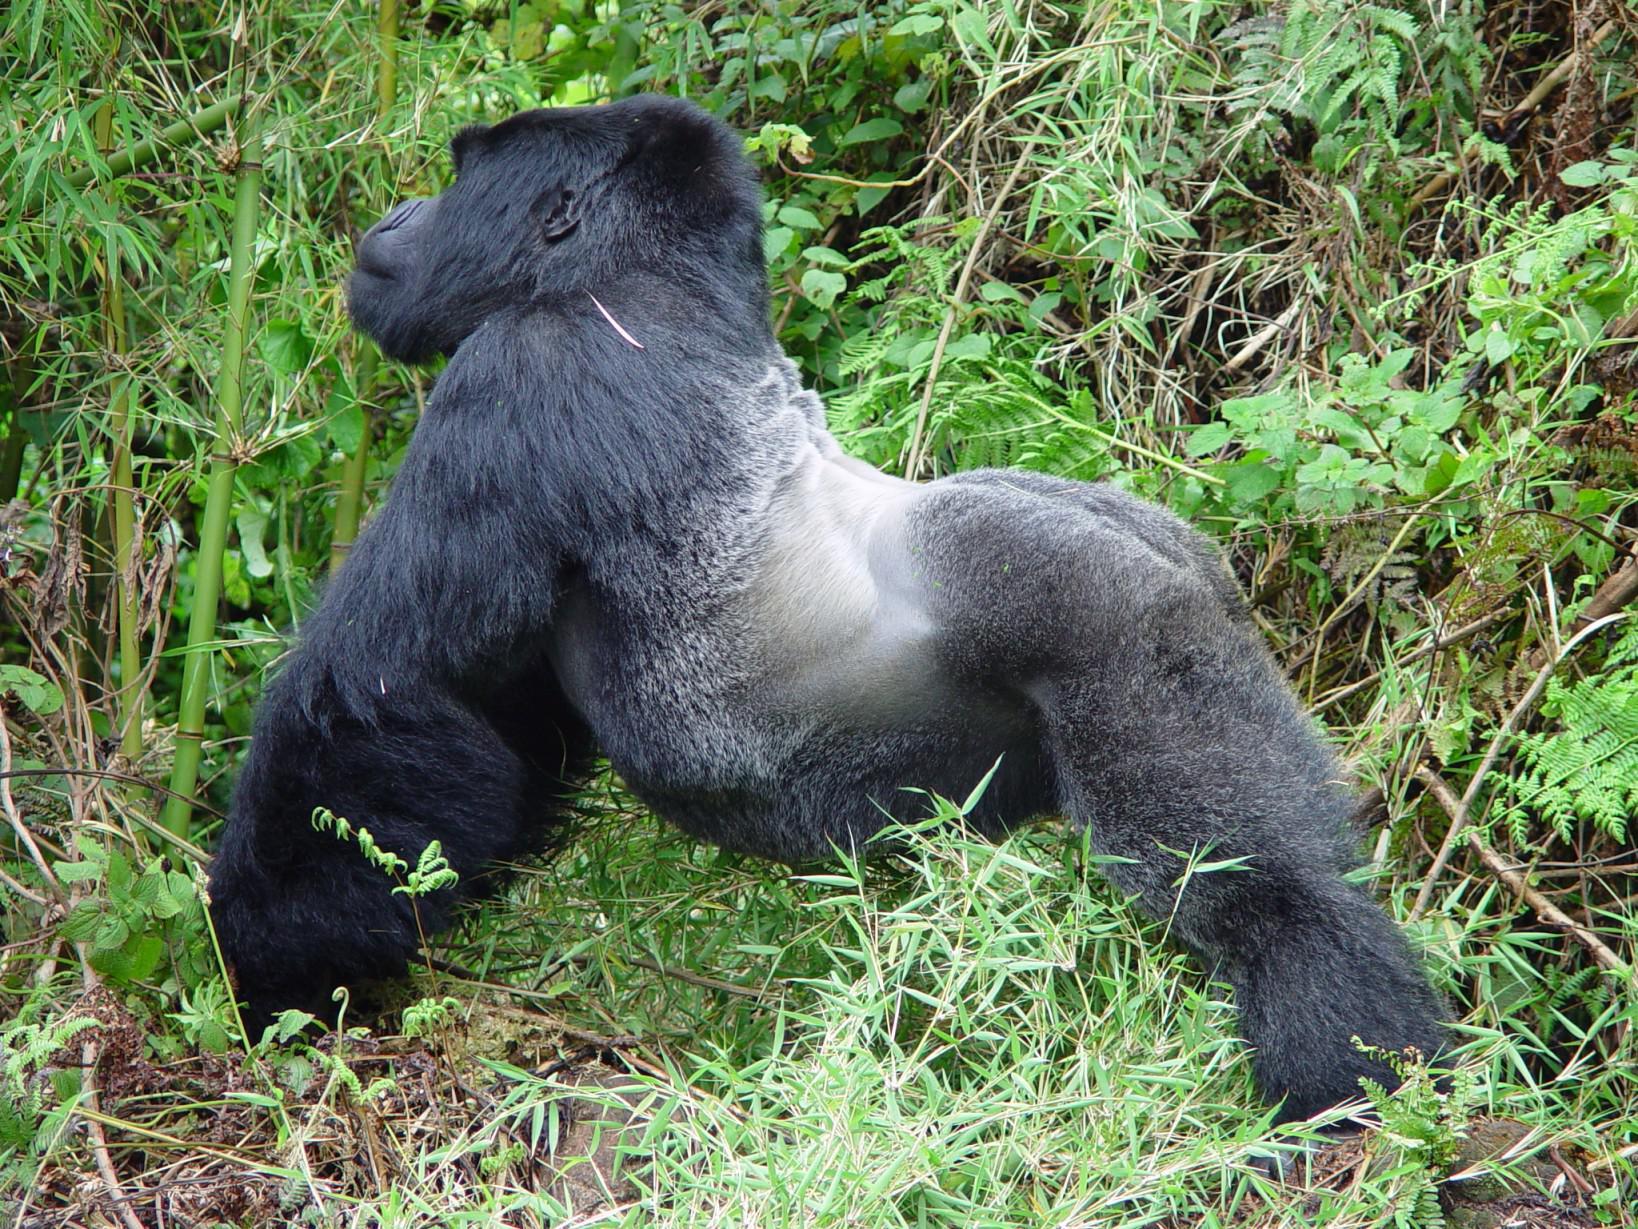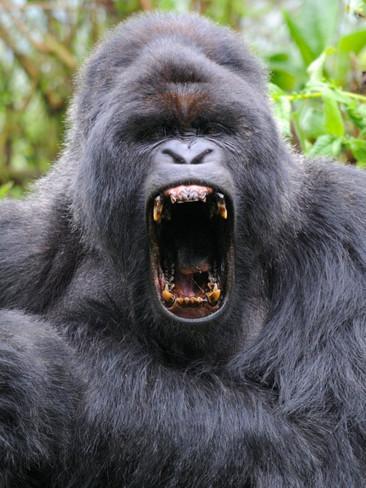The first image is the image on the left, the second image is the image on the right. Examine the images to the left and right. Is the description "Right image shows a young gorilla held on the chest of an adult gorilla, surrounded by foliage." accurate? Answer yes or no. No. The first image is the image on the left, the second image is the image on the right. Evaluate the accuracy of this statement regarding the images: "At least one baby gorilla is cuddled up with it's mother.". Is it true? Answer yes or no. No. 